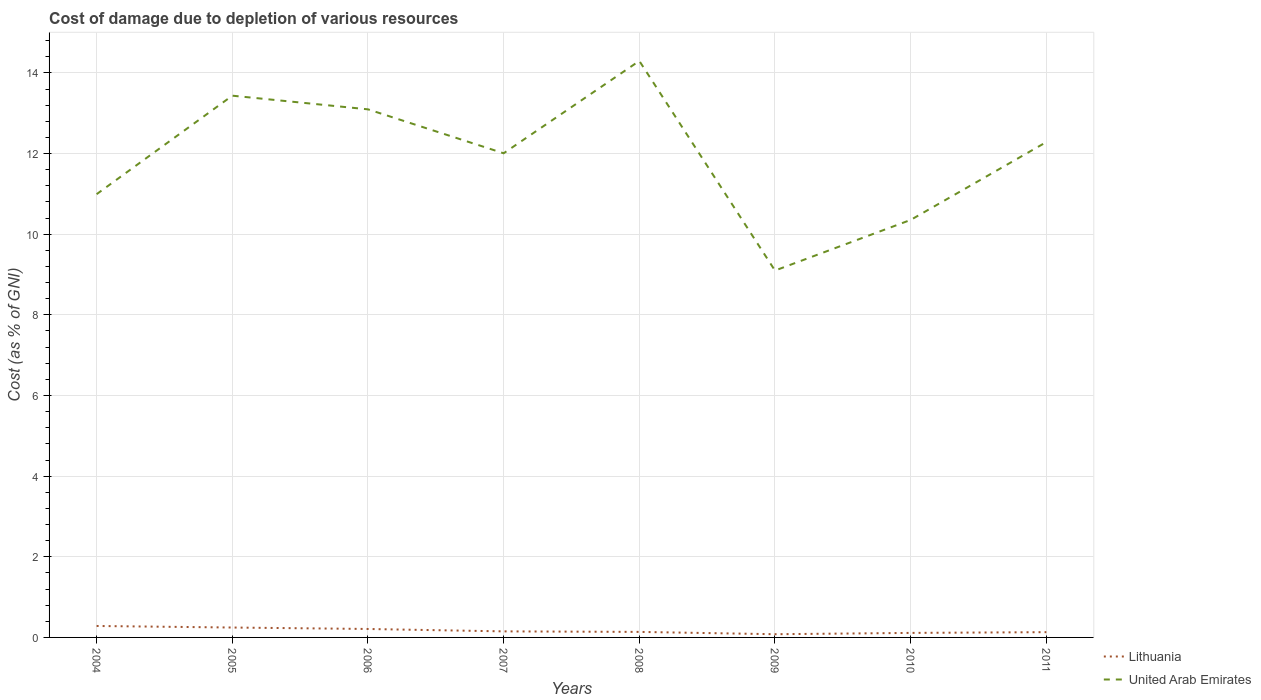Does the line corresponding to Lithuania intersect with the line corresponding to United Arab Emirates?
Offer a very short reply. No. Across all years, what is the maximum cost of damage caused due to the depletion of various resources in Lithuania?
Your response must be concise. 0.08. What is the total cost of damage caused due to the depletion of various resources in Lithuania in the graph?
Ensure brevity in your answer.  0.07. What is the difference between the highest and the second highest cost of damage caused due to the depletion of various resources in Lithuania?
Keep it short and to the point. 0.2. Is the cost of damage caused due to the depletion of various resources in Lithuania strictly greater than the cost of damage caused due to the depletion of various resources in United Arab Emirates over the years?
Ensure brevity in your answer.  Yes. How many lines are there?
Your answer should be very brief. 2. How many years are there in the graph?
Offer a terse response. 8. What is the difference between two consecutive major ticks on the Y-axis?
Ensure brevity in your answer.  2. Are the values on the major ticks of Y-axis written in scientific E-notation?
Keep it short and to the point. No. How are the legend labels stacked?
Offer a very short reply. Vertical. What is the title of the graph?
Provide a succinct answer. Cost of damage due to depletion of various resources. Does "Other small states" appear as one of the legend labels in the graph?
Ensure brevity in your answer.  No. What is the label or title of the X-axis?
Your answer should be very brief. Years. What is the label or title of the Y-axis?
Your answer should be very brief. Cost (as % of GNI). What is the Cost (as % of GNI) of Lithuania in 2004?
Provide a short and direct response. 0.28. What is the Cost (as % of GNI) of United Arab Emirates in 2004?
Make the answer very short. 10.99. What is the Cost (as % of GNI) in Lithuania in 2005?
Make the answer very short. 0.25. What is the Cost (as % of GNI) in United Arab Emirates in 2005?
Give a very brief answer. 13.44. What is the Cost (as % of GNI) in Lithuania in 2006?
Offer a very short reply. 0.21. What is the Cost (as % of GNI) in United Arab Emirates in 2006?
Ensure brevity in your answer.  13.1. What is the Cost (as % of GNI) in Lithuania in 2007?
Give a very brief answer. 0.15. What is the Cost (as % of GNI) in United Arab Emirates in 2007?
Keep it short and to the point. 12.01. What is the Cost (as % of GNI) of Lithuania in 2008?
Your answer should be compact. 0.14. What is the Cost (as % of GNI) in United Arab Emirates in 2008?
Offer a terse response. 14.3. What is the Cost (as % of GNI) in Lithuania in 2009?
Keep it short and to the point. 0.08. What is the Cost (as % of GNI) of United Arab Emirates in 2009?
Your response must be concise. 9.1. What is the Cost (as % of GNI) in Lithuania in 2010?
Provide a succinct answer. 0.11. What is the Cost (as % of GNI) in United Arab Emirates in 2010?
Ensure brevity in your answer.  10.35. What is the Cost (as % of GNI) in Lithuania in 2011?
Your answer should be compact. 0.13. What is the Cost (as % of GNI) of United Arab Emirates in 2011?
Ensure brevity in your answer.  12.28. Across all years, what is the maximum Cost (as % of GNI) of Lithuania?
Your response must be concise. 0.28. Across all years, what is the maximum Cost (as % of GNI) of United Arab Emirates?
Your response must be concise. 14.3. Across all years, what is the minimum Cost (as % of GNI) in Lithuania?
Your answer should be compact. 0.08. Across all years, what is the minimum Cost (as % of GNI) in United Arab Emirates?
Ensure brevity in your answer.  9.1. What is the total Cost (as % of GNI) of Lithuania in the graph?
Make the answer very short. 1.35. What is the total Cost (as % of GNI) of United Arab Emirates in the graph?
Give a very brief answer. 95.57. What is the difference between the Cost (as % of GNI) of Lithuania in 2004 and that in 2005?
Keep it short and to the point. 0.04. What is the difference between the Cost (as % of GNI) of United Arab Emirates in 2004 and that in 2005?
Make the answer very short. -2.44. What is the difference between the Cost (as % of GNI) of Lithuania in 2004 and that in 2006?
Offer a very short reply. 0.07. What is the difference between the Cost (as % of GNI) in United Arab Emirates in 2004 and that in 2006?
Give a very brief answer. -2.1. What is the difference between the Cost (as % of GNI) in Lithuania in 2004 and that in 2007?
Offer a very short reply. 0.13. What is the difference between the Cost (as % of GNI) of United Arab Emirates in 2004 and that in 2007?
Your answer should be compact. -1.01. What is the difference between the Cost (as % of GNI) in Lithuania in 2004 and that in 2008?
Provide a succinct answer. 0.15. What is the difference between the Cost (as % of GNI) in United Arab Emirates in 2004 and that in 2008?
Your answer should be very brief. -3.31. What is the difference between the Cost (as % of GNI) in Lithuania in 2004 and that in 2009?
Keep it short and to the point. 0.2. What is the difference between the Cost (as % of GNI) of United Arab Emirates in 2004 and that in 2009?
Keep it short and to the point. 1.89. What is the difference between the Cost (as % of GNI) of Lithuania in 2004 and that in 2010?
Ensure brevity in your answer.  0.17. What is the difference between the Cost (as % of GNI) in United Arab Emirates in 2004 and that in 2010?
Your answer should be very brief. 0.64. What is the difference between the Cost (as % of GNI) in Lithuania in 2004 and that in 2011?
Your answer should be very brief. 0.15. What is the difference between the Cost (as % of GNI) in United Arab Emirates in 2004 and that in 2011?
Provide a succinct answer. -1.29. What is the difference between the Cost (as % of GNI) in Lithuania in 2005 and that in 2006?
Provide a short and direct response. 0.04. What is the difference between the Cost (as % of GNI) of United Arab Emirates in 2005 and that in 2006?
Ensure brevity in your answer.  0.34. What is the difference between the Cost (as % of GNI) in Lithuania in 2005 and that in 2007?
Make the answer very short. 0.1. What is the difference between the Cost (as % of GNI) of United Arab Emirates in 2005 and that in 2007?
Ensure brevity in your answer.  1.43. What is the difference between the Cost (as % of GNI) in Lithuania in 2005 and that in 2008?
Offer a terse response. 0.11. What is the difference between the Cost (as % of GNI) in United Arab Emirates in 2005 and that in 2008?
Keep it short and to the point. -0.86. What is the difference between the Cost (as % of GNI) of Lithuania in 2005 and that in 2009?
Your answer should be compact. 0.17. What is the difference between the Cost (as % of GNI) in United Arab Emirates in 2005 and that in 2009?
Make the answer very short. 4.34. What is the difference between the Cost (as % of GNI) of Lithuania in 2005 and that in 2010?
Provide a short and direct response. 0.13. What is the difference between the Cost (as % of GNI) of United Arab Emirates in 2005 and that in 2010?
Your answer should be very brief. 3.08. What is the difference between the Cost (as % of GNI) in Lithuania in 2005 and that in 2011?
Provide a short and direct response. 0.11. What is the difference between the Cost (as % of GNI) in United Arab Emirates in 2005 and that in 2011?
Your response must be concise. 1.15. What is the difference between the Cost (as % of GNI) of Lithuania in 2006 and that in 2007?
Make the answer very short. 0.06. What is the difference between the Cost (as % of GNI) of United Arab Emirates in 2006 and that in 2007?
Your answer should be very brief. 1.09. What is the difference between the Cost (as % of GNI) in Lithuania in 2006 and that in 2008?
Keep it short and to the point. 0.07. What is the difference between the Cost (as % of GNI) of United Arab Emirates in 2006 and that in 2008?
Offer a terse response. -1.2. What is the difference between the Cost (as % of GNI) of Lithuania in 2006 and that in 2009?
Ensure brevity in your answer.  0.13. What is the difference between the Cost (as % of GNI) in United Arab Emirates in 2006 and that in 2009?
Offer a terse response. 4. What is the difference between the Cost (as % of GNI) in Lithuania in 2006 and that in 2010?
Your response must be concise. 0.1. What is the difference between the Cost (as % of GNI) in United Arab Emirates in 2006 and that in 2010?
Keep it short and to the point. 2.74. What is the difference between the Cost (as % of GNI) of Lithuania in 2006 and that in 2011?
Make the answer very short. 0.08. What is the difference between the Cost (as % of GNI) in United Arab Emirates in 2006 and that in 2011?
Your answer should be compact. 0.81. What is the difference between the Cost (as % of GNI) in Lithuania in 2007 and that in 2008?
Make the answer very short. 0.01. What is the difference between the Cost (as % of GNI) of United Arab Emirates in 2007 and that in 2008?
Offer a very short reply. -2.29. What is the difference between the Cost (as % of GNI) in Lithuania in 2007 and that in 2009?
Offer a terse response. 0.07. What is the difference between the Cost (as % of GNI) in United Arab Emirates in 2007 and that in 2009?
Provide a short and direct response. 2.91. What is the difference between the Cost (as % of GNI) of Lithuania in 2007 and that in 2010?
Provide a succinct answer. 0.04. What is the difference between the Cost (as % of GNI) of United Arab Emirates in 2007 and that in 2010?
Make the answer very short. 1.65. What is the difference between the Cost (as % of GNI) in Lithuania in 2007 and that in 2011?
Your answer should be very brief. 0.02. What is the difference between the Cost (as % of GNI) of United Arab Emirates in 2007 and that in 2011?
Your answer should be very brief. -0.28. What is the difference between the Cost (as % of GNI) in Lithuania in 2008 and that in 2009?
Offer a terse response. 0.06. What is the difference between the Cost (as % of GNI) in United Arab Emirates in 2008 and that in 2009?
Provide a short and direct response. 5.2. What is the difference between the Cost (as % of GNI) of Lithuania in 2008 and that in 2010?
Provide a short and direct response. 0.03. What is the difference between the Cost (as % of GNI) in United Arab Emirates in 2008 and that in 2010?
Offer a very short reply. 3.94. What is the difference between the Cost (as % of GNI) of Lithuania in 2008 and that in 2011?
Give a very brief answer. 0.01. What is the difference between the Cost (as % of GNI) of United Arab Emirates in 2008 and that in 2011?
Provide a succinct answer. 2.01. What is the difference between the Cost (as % of GNI) in Lithuania in 2009 and that in 2010?
Provide a short and direct response. -0.03. What is the difference between the Cost (as % of GNI) in United Arab Emirates in 2009 and that in 2010?
Your response must be concise. -1.26. What is the difference between the Cost (as % of GNI) in Lithuania in 2009 and that in 2011?
Your response must be concise. -0.05. What is the difference between the Cost (as % of GNI) of United Arab Emirates in 2009 and that in 2011?
Ensure brevity in your answer.  -3.19. What is the difference between the Cost (as % of GNI) of Lithuania in 2010 and that in 2011?
Ensure brevity in your answer.  -0.02. What is the difference between the Cost (as % of GNI) of United Arab Emirates in 2010 and that in 2011?
Ensure brevity in your answer.  -1.93. What is the difference between the Cost (as % of GNI) in Lithuania in 2004 and the Cost (as % of GNI) in United Arab Emirates in 2005?
Ensure brevity in your answer.  -13.15. What is the difference between the Cost (as % of GNI) of Lithuania in 2004 and the Cost (as % of GNI) of United Arab Emirates in 2006?
Your answer should be very brief. -12.81. What is the difference between the Cost (as % of GNI) of Lithuania in 2004 and the Cost (as % of GNI) of United Arab Emirates in 2007?
Give a very brief answer. -11.72. What is the difference between the Cost (as % of GNI) of Lithuania in 2004 and the Cost (as % of GNI) of United Arab Emirates in 2008?
Your answer should be very brief. -14.01. What is the difference between the Cost (as % of GNI) of Lithuania in 2004 and the Cost (as % of GNI) of United Arab Emirates in 2009?
Offer a terse response. -8.81. What is the difference between the Cost (as % of GNI) of Lithuania in 2004 and the Cost (as % of GNI) of United Arab Emirates in 2010?
Keep it short and to the point. -10.07. What is the difference between the Cost (as % of GNI) in Lithuania in 2004 and the Cost (as % of GNI) in United Arab Emirates in 2011?
Offer a very short reply. -12. What is the difference between the Cost (as % of GNI) in Lithuania in 2005 and the Cost (as % of GNI) in United Arab Emirates in 2006?
Your answer should be compact. -12.85. What is the difference between the Cost (as % of GNI) of Lithuania in 2005 and the Cost (as % of GNI) of United Arab Emirates in 2007?
Your response must be concise. -11.76. What is the difference between the Cost (as % of GNI) of Lithuania in 2005 and the Cost (as % of GNI) of United Arab Emirates in 2008?
Give a very brief answer. -14.05. What is the difference between the Cost (as % of GNI) of Lithuania in 2005 and the Cost (as % of GNI) of United Arab Emirates in 2009?
Offer a terse response. -8.85. What is the difference between the Cost (as % of GNI) of Lithuania in 2005 and the Cost (as % of GNI) of United Arab Emirates in 2010?
Give a very brief answer. -10.11. What is the difference between the Cost (as % of GNI) in Lithuania in 2005 and the Cost (as % of GNI) in United Arab Emirates in 2011?
Offer a very short reply. -12.04. What is the difference between the Cost (as % of GNI) of Lithuania in 2006 and the Cost (as % of GNI) of United Arab Emirates in 2007?
Your answer should be compact. -11.8. What is the difference between the Cost (as % of GNI) in Lithuania in 2006 and the Cost (as % of GNI) in United Arab Emirates in 2008?
Your answer should be very brief. -14.09. What is the difference between the Cost (as % of GNI) of Lithuania in 2006 and the Cost (as % of GNI) of United Arab Emirates in 2009?
Offer a terse response. -8.89. What is the difference between the Cost (as % of GNI) in Lithuania in 2006 and the Cost (as % of GNI) in United Arab Emirates in 2010?
Offer a very short reply. -10.14. What is the difference between the Cost (as % of GNI) in Lithuania in 2006 and the Cost (as % of GNI) in United Arab Emirates in 2011?
Ensure brevity in your answer.  -12.08. What is the difference between the Cost (as % of GNI) of Lithuania in 2007 and the Cost (as % of GNI) of United Arab Emirates in 2008?
Provide a short and direct response. -14.15. What is the difference between the Cost (as % of GNI) in Lithuania in 2007 and the Cost (as % of GNI) in United Arab Emirates in 2009?
Offer a terse response. -8.95. What is the difference between the Cost (as % of GNI) of Lithuania in 2007 and the Cost (as % of GNI) of United Arab Emirates in 2010?
Your response must be concise. -10.2. What is the difference between the Cost (as % of GNI) in Lithuania in 2007 and the Cost (as % of GNI) in United Arab Emirates in 2011?
Provide a succinct answer. -12.13. What is the difference between the Cost (as % of GNI) of Lithuania in 2008 and the Cost (as % of GNI) of United Arab Emirates in 2009?
Your response must be concise. -8.96. What is the difference between the Cost (as % of GNI) in Lithuania in 2008 and the Cost (as % of GNI) in United Arab Emirates in 2010?
Provide a succinct answer. -10.22. What is the difference between the Cost (as % of GNI) of Lithuania in 2008 and the Cost (as % of GNI) of United Arab Emirates in 2011?
Provide a succinct answer. -12.15. What is the difference between the Cost (as % of GNI) of Lithuania in 2009 and the Cost (as % of GNI) of United Arab Emirates in 2010?
Provide a short and direct response. -10.27. What is the difference between the Cost (as % of GNI) in Lithuania in 2009 and the Cost (as % of GNI) in United Arab Emirates in 2011?
Your answer should be compact. -12.21. What is the difference between the Cost (as % of GNI) in Lithuania in 2010 and the Cost (as % of GNI) in United Arab Emirates in 2011?
Provide a succinct answer. -12.17. What is the average Cost (as % of GNI) of Lithuania per year?
Offer a terse response. 0.17. What is the average Cost (as % of GNI) of United Arab Emirates per year?
Offer a very short reply. 11.95. In the year 2004, what is the difference between the Cost (as % of GNI) of Lithuania and Cost (as % of GNI) of United Arab Emirates?
Offer a very short reply. -10.71. In the year 2005, what is the difference between the Cost (as % of GNI) of Lithuania and Cost (as % of GNI) of United Arab Emirates?
Ensure brevity in your answer.  -13.19. In the year 2006, what is the difference between the Cost (as % of GNI) in Lithuania and Cost (as % of GNI) in United Arab Emirates?
Offer a very short reply. -12.89. In the year 2007, what is the difference between the Cost (as % of GNI) in Lithuania and Cost (as % of GNI) in United Arab Emirates?
Provide a short and direct response. -11.86. In the year 2008, what is the difference between the Cost (as % of GNI) of Lithuania and Cost (as % of GNI) of United Arab Emirates?
Give a very brief answer. -14.16. In the year 2009, what is the difference between the Cost (as % of GNI) in Lithuania and Cost (as % of GNI) in United Arab Emirates?
Make the answer very short. -9.02. In the year 2010, what is the difference between the Cost (as % of GNI) in Lithuania and Cost (as % of GNI) in United Arab Emirates?
Offer a very short reply. -10.24. In the year 2011, what is the difference between the Cost (as % of GNI) of Lithuania and Cost (as % of GNI) of United Arab Emirates?
Make the answer very short. -12.15. What is the ratio of the Cost (as % of GNI) of Lithuania in 2004 to that in 2005?
Provide a short and direct response. 1.16. What is the ratio of the Cost (as % of GNI) in United Arab Emirates in 2004 to that in 2005?
Ensure brevity in your answer.  0.82. What is the ratio of the Cost (as % of GNI) in Lithuania in 2004 to that in 2006?
Offer a very short reply. 1.36. What is the ratio of the Cost (as % of GNI) of United Arab Emirates in 2004 to that in 2006?
Keep it short and to the point. 0.84. What is the ratio of the Cost (as % of GNI) of Lithuania in 2004 to that in 2007?
Give a very brief answer. 1.89. What is the ratio of the Cost (as % of GNI) in United Arab Emirates in 2004 to that in 2007?
Offer a very short reply. 0.92. What is the ratio of the Cost (as % of GNI) of Lithuania in 2004 to that in 2008?
Give a very brief answer. 2.07. What is the ratio of the Cost (as % of GNI) in United Arab Emirates in 2004 to that in 2008?
Your response must be concise. 0.77. What is the ratio of the Cost (as % of GNI) in Lithuania in 2004 to that in 2009?
Provide a short and direct response. 3.57. What is the ratio of the Cost (as % of GNI) in United Arab Emirates in 2004 to that in 2009?
Your answer should be very brief. 1.21. What is the ratio of the Cost (as % of GNI) in Lithuania in 2004 to that in 2010?
Your response must be concise. 2.53. What is the ratio of the Cost (as % of GNI) in United Arab Emirates in 2004 to that in 2010?
Your answer should be very brief. 1.06. What is the ratio of the Cost (as % of GNI) in Lithuania in 2004 to that in 2011?
Your answer should be very brief. 2.17. What is the ratio of the Cost (as % of GNI) in United Arab Emirates in 2004 to that in 2011?
Provide a succinct answer. 0.89. What is the ratio of the Cost (as % of GNI) of Lithuania in 2005 to that in 2006?
Your answer should be compact. 1.17. What is the ratio of the Cost (as % of GNI) in United Arab Emirates in 2005 to that in 2006?
Provide a short and direct response. 1.03. What is the ratio of the Cost (as % of GNI) of Lithuania in 2005 to that in 2007?
Offer a terse response. 1.63. What is the ratio of the Cost (as % of GNI) in United Arab Emirates in 2005 to that in 2007?
Your answer should be very brief. 1.12. What is the ratio of the Cost (as % of GNI) in Lithuania in 2005 to that in 2008?
Your answer should be compact. 1.79. What is the ratio of the Cost (as % of GNI) in United Arab Emirates in 2005 to that in 2008?
Offer a very short reply. 0.94. What is the ratio of the Cost (as % of GNI) in Lithuania in 2005 to that in 2009?
Provide a short and direct response. 3.09. What is the ratio of the Cost (as % of GNI) of United Arab Emirates in 2005 to that in 2009?
Your answer should be compact. 1.48. What is the ratio of the Cost (as % of GNI) in Lithuania in 2005 to that in 2010?
Your answer should be compact. 2.19. What is the ratio of the Cost (as % of GNI) in United Arab Emirates in 2005 to that in 2010?
Offer a very short reply. 1.3. What is the ratio of the Cost (as % of GNI) in Lithuania in 2005 to that in 2011?
Provide a short and direct response. 1.88. What is the ratio of the Cost (as % of GNI) of United Arab Emirates in 2005 to that in 2011?
Offer a very short reply. 1.09. What is the ratio of the Cost (as % of GNI) in Lithuania in 2006 to that in 2007?
Offer a terse response. 1.39. What is the ratio of the Cost (as % of GNI) in United Arab Emirates in 2006 to that in 2007?
Your response must be concise. 1.09. What is the ratio of the Cost (as % of GNI) of Lithuania in 2006 to that in 2008?
Your answer should be compact. 1.53. What is the ratio of the Cost (as % of GNI) in United Arab Emirates in 2006 to that in 2008?
Make the answer very short. 0.92. What is the ratio of the Cost (as % of GNI) in Lithuania in 2006 to that in 2009?
Provide a short and direct response. 2.63. What is the ratio of the Cost (as % of GNI) of United Arab Emirates in 2006 to that in 2009?
Your response must be concise. 1.44. What is the ratio of the Cost (as % of GNI) in Lithuania in 2006 to that in 2010?
Provide a succinct answer. 1.87. What is the ratio of the Cost (as % of GNI) in United Arab Emirates in 2006 to that in 2010?
Give a very brief answer. 1.26. What is the ratio of the Cost (as % of GNI) of Lithuania in 2006 to that in 2011?
Offer a terse response. 1.6. What is the ratio of the Cost (as % of GNI) in United Arab Emirates in 2006 to that in 2011?
Provide a short and direct response. 1.07. What is the ratio of the Cost (as % of GNI) in Lithuania in 2007 to that in 2008?
Your answer should be very brief. 1.1. What is the ratio of the Cost (as % of GNI) in United Arab Emirates in 2007 to that in 2008?
Offer a very short reply. 0.84. What is the ratio of the Cost (as % of GNI) in Lithuania in 2007 to that in 2009?
Provide a succinct answer. 1.89. What is the ratio of the Cost (as % of GNI) in United Arab Emirates in 2007 to that in 2009?
Offer a very short reply. 1.32. What is the ratio of the Cost (as % of GNI) of Lithuania in 2007 to that in 2010?
Offer a terse response. 1.34. What is the ratio of the Cost (as % of GNI) in United Arab Emirates in 2007 to that in 2010?
Your response must be concise. 1.16. What is the ratio of the Cost (as % of GNI) in Lithuania in 2007 to that in 2011?
Provide a short and direct response. 1.15. What is the ratio of the Cost (as % of GNI) of United Arab Emirates in 2007 to that in 2011?
Your answer should be compact. 0.98. What is the ratio of the Cost (as % of GNI) in Lithuania in 2008 to that in 2009?
Your answer should be compact. 1.72. What is the ratio of the Cost (as % of GNI) of United Arab Emirates in 2008 to that in 2009?
Your response must be concise. 1.57. What is the ratio of the Cost (as % of GNI) of Lithuania in 2008 to that in 2010?
Provide a succinct answer. 1.22. What is the ratio of the Cost (as % of GNI) in United Arab Emirates in 2008 to that in 2010?
Offer a terse response. 1.38. What is the ratio of the Cost (as % of GNI) in Lithuania in 2008 to that in 2011?
Offer a terse response. 1.05. What is the ratio of the Cost (as % of GNI) of United Arab Emirates in 2008 to that in 2011?
Give a very brief answer. 1.16. What is the ratio of the Cost (as % of GNI) of Lithuania in 2009 to that in 2010?
Your answer should be very brief. 0.71. What is the ratio of the Cost (as % of GNI) of United Arab Emirates in 2009 to that in 2010?
Your answer should be very brief. 0.88. What is the ratio of the Cost (as % of GNI) of Lithuania in 2009 to that in 2011?
Your answer should be compact. 0.61. What is the ratio of the Cost (as % of GNI) in United Arab Emirates in 2009 to that in 2011?
Your answer should be compact. 0.74. What is the ratio of the Cost (as % of GNI) in Lithuania in 2010 to that in 2011?
Ensure brevity in your answer.  0.86. What is the ratio of the Cost (as % of GNI) of United Arab Emirates in 2010 to that in 2011?
Offer a very short reply. 0.84. What is the difference between the highest and the second highest Cost (as % of GNI) of Lithuania?
Provide a short and direct response. 0.04. What is the difference between the highest and the second highest Cost (as % of GNI) of United Arab Emirates?
Your answer should be compact. 0.86. What is the difference between the highest and the lowest Cost (as % of GNI) in Lithuania?
Provide a succinct answer. 0.2. What is the difference between the highest and the lowest Cost (as % of GNI) of United Arab Emirates?
Your answer should be very brief. 5.2. 